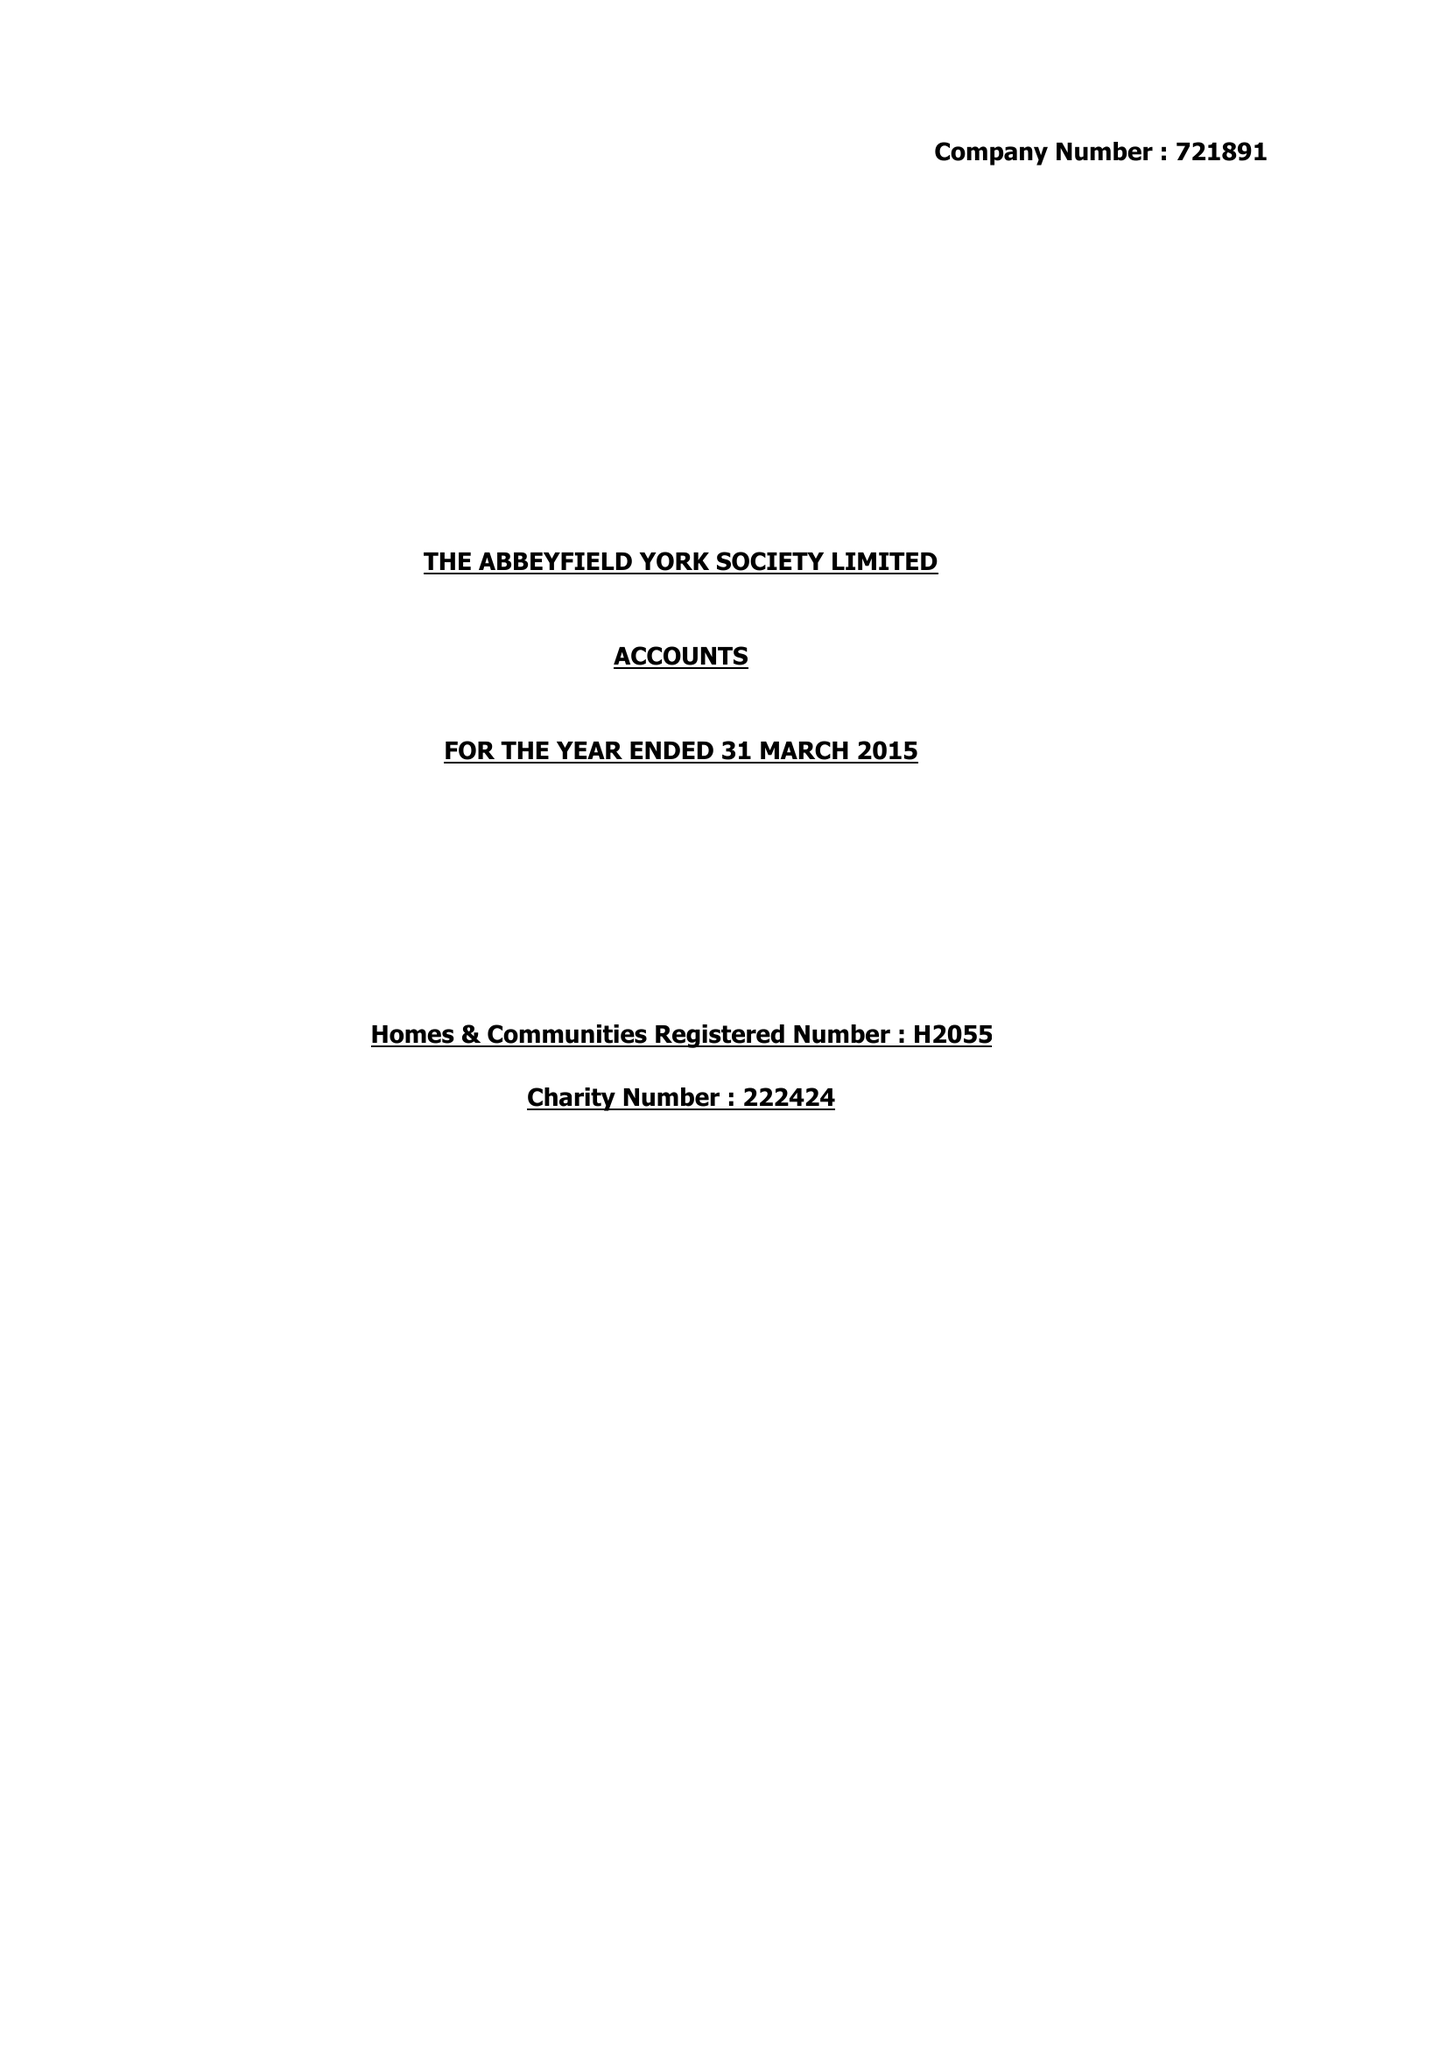What is the value for the charity_name?
Answer the question using a single word or phrase. The Abbeyfield York Society Ltd. 